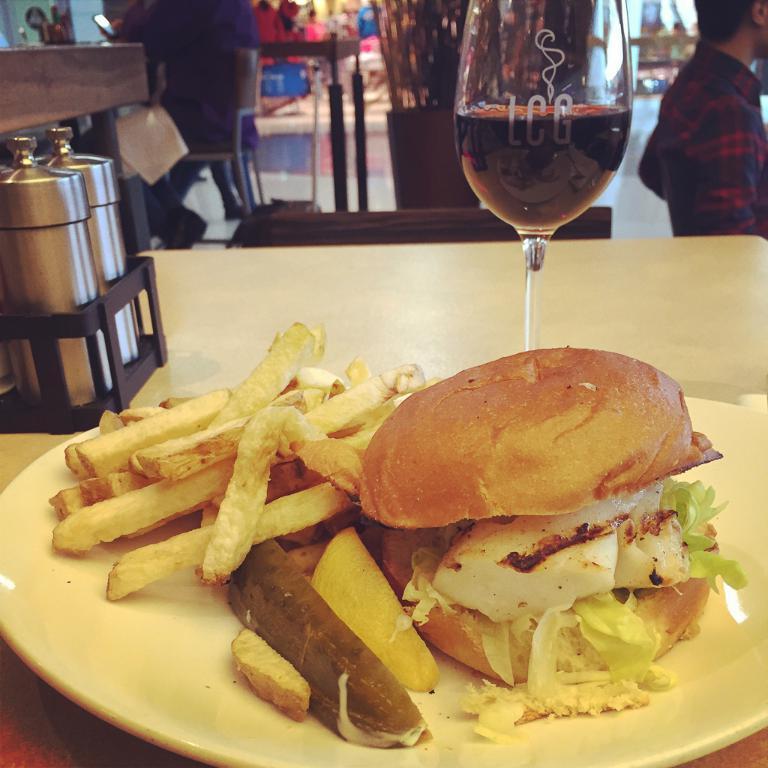Please provide a concise description of this image. In the foreground of the picture there is a table, on the table there are glass, jars, plate and food items. In the background there are tables, chairs, desk, people and other objects. 